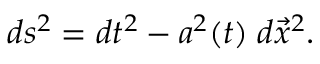<formula> <loc_0><loc_0><loc_500><loc_500>d s ^ { 2 } = d t ^ { 2 } - a ^ { 2 } ( t ) \, d \vec { x } ^ { 2 } .</formula> 